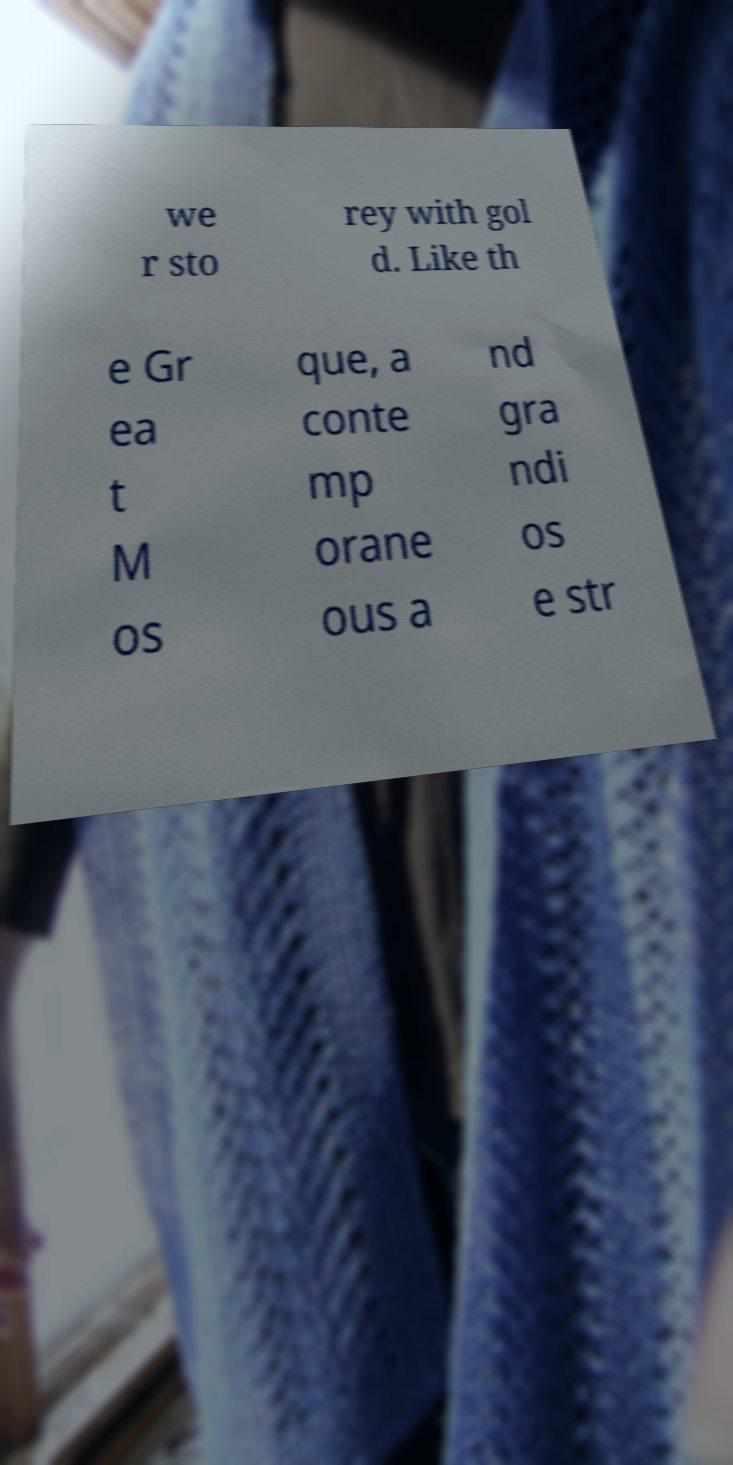Could you assist in decoding the text presented in this image and type it out clearly? we r sto rey with gol d. Like th e Gr ea t M os que, a conte mp orane ous a nd gra ndi os e str 